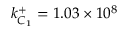Convert formula to latex. <formula><loc_0><loc_0><loc_500><loc_500>k _ { C _ { 1 } } ^ { + } = 1 . 0 3 \times 1 0 ^ { 8 }</formula> 